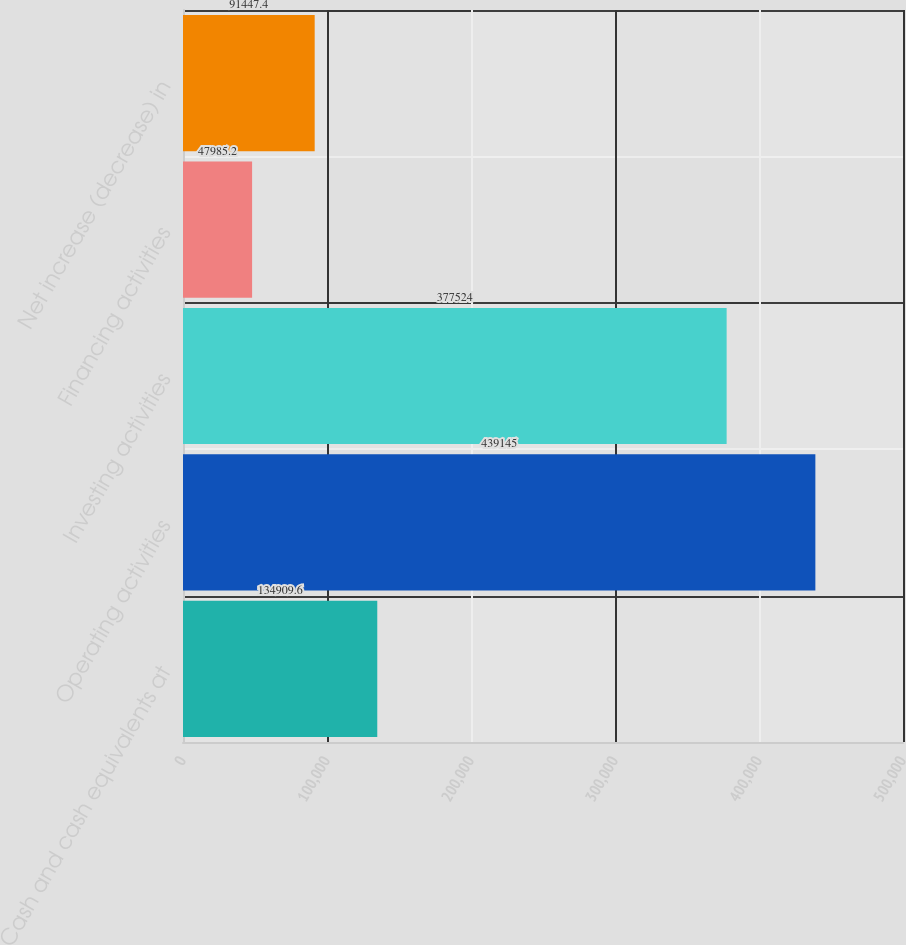Convert chart to OTSL. <chart><loc_0><loc_0><loc_500><loc_500><bar_chart><fcel>Cash and cash equivalents at<fcel>Operating activities<fcel>Investing activities<fcel>Financing activities<fcel>Net increase (decrease) in<nl><fcel>134910<fcel>439145<fcel>377524<fcel>47985.2<fcel>91447.4<nl></chart> 